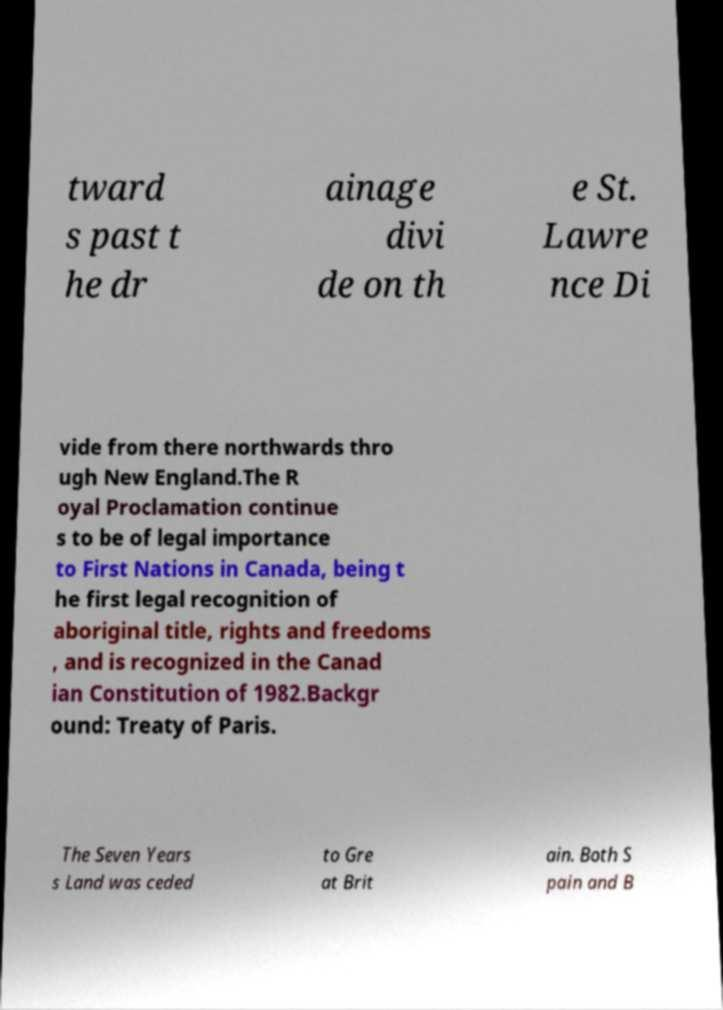For documentation purposes, I need the text within this image transcribed. Could you provide that? tward s past t he dr ainage divi de on th e St. Lawre nce Di vide from there northwards thro ugh New England.The R oyal Proclamation continue s to be of legal importance to First Nations in Canada, being t he first legal recognition of aboriginal title, rights and freedoms , and is recognized in the Canad ian Constitution of 1982.Backgr ound: Treaty of Paris. The Seven Years s Land was ceded to Gre at Brit ain. Both S pain and B 